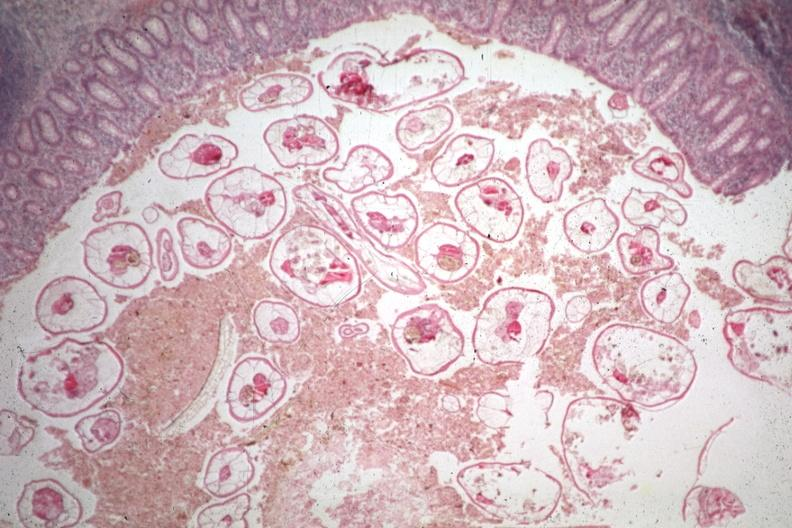does acid show typical excellent pinworm?
Answer the question using a single word or phrase. No 